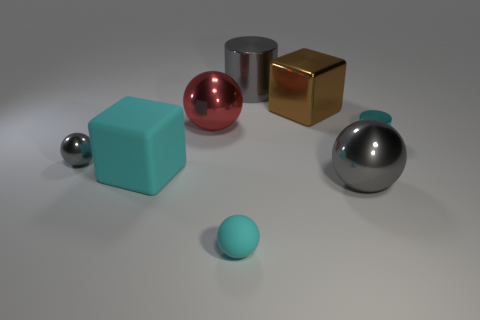Add 1 cyan balls. How many objects exist? 9 Subtract all blocks. How many objects are left? 6 Add 8 cyan blocks. How many cyan blocks are left? 9 Add 1 cyan cylinders. How many cyan cylinders exist? 2 Subtract 0 red blocks. How many objects are left? 8 Subtract all tiny rubber things. Subtract all tiny gray objects. How many objects are left? 6 